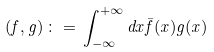<formula> <loc_0><loc_0><loc_500><loc_500>( f , g ) \, \colon = \, \int _ { - \infty } ^ { + \infty } d x \bar { f } ( x ) g ( x )</formula> 